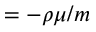<formula> <loc_0><loc_0><loc_500><loc_500>= - \rho \mu / m</formula> 